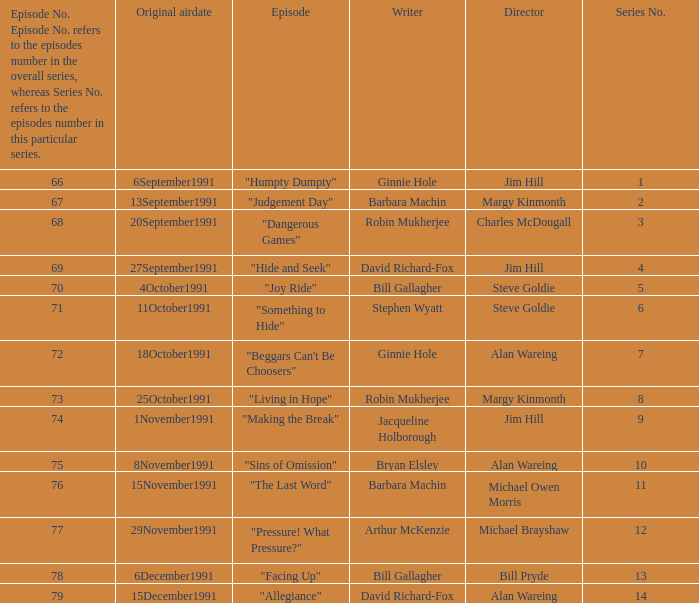Name the original airdate for robin mukherjee and margy kinmonth 25October1991. 